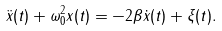Convert formula to latex. <formula><loc_0><loc_0><loc_500><loc_500>\ddot { x } ( t ) + \omega _ { 0 } ^ { 2 } x ( t ) = - 2 \beta \dot { x } ( t ) + \xi ( t ) .</formula> 